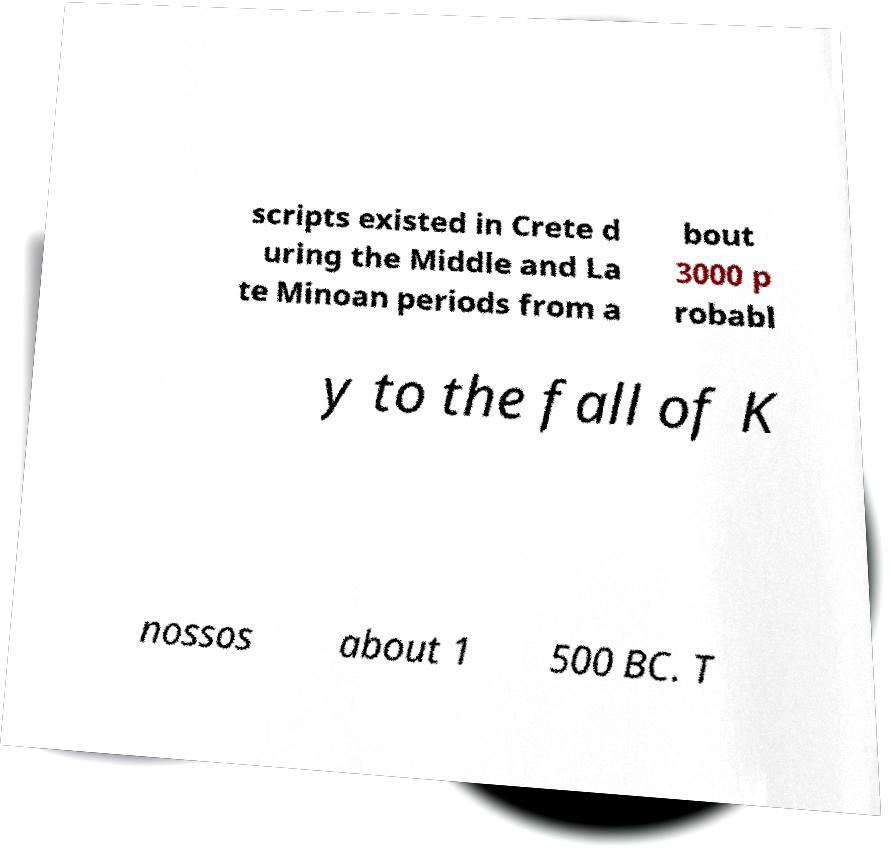Please read and relay the text visible in this image. What does it say? scripts existed in Crete d uring the Middle and La te Minoan periods from a bout 3000 p robabl y to the fall of K nossos about 1 500 BC. T 